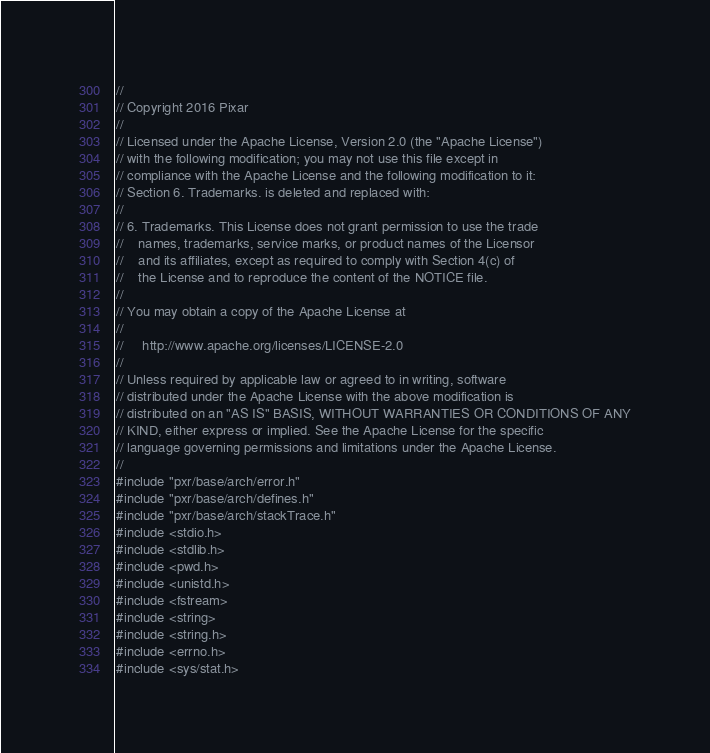Convert code to text. <code><loc_0><loc_0><loc_500><loc_500><_C++_>//
// Copyright 2016 Pixar
//
// Licensed under the Apache License, Version 2.0 (the "Apache License")
// with the following modification; you may not use this file except in
// compliance with the Apache License and the following modification to it:
// Section 6. Trademarks. is deleted and replaced with:
//
// 6. Trademarks. This License does not grant permission to use the trade
//    names, trademarks, service marks, or product names of the Licensor
//    and its affiliates, except as required to comply with Section 4(c) of
//    the License and to reproduce the content of the NOTICE file.
//
// You may obtain a copy of the Apache License at
//
//     http://www.apache.org/licenses/LICENSE-2.0
//
// Unless required by applicable law or agreed to in writing, software
// distributed under the Apache License with the above modification is
// distributed on an "AS IS" BASIS, WITHOUT WARRANTIES OR CONDITIONS OF ANY
// KIND, either express or implied. See the Apache License for the specific
// language governing permissions and limitations under the Apache License.
//
#include "pxr/base/arch/error.h"
#include "pxr/base/arch/defines.h"
#include "pxr/base/arch/stackTrace.h"
#include <stdio.h>
#include <stdlib.h>
#include <pwd.h>
#include <unistd.h>
#include <fstream>
#include <string>
#include <string.h>
#include <errno.h>
#include <sys/stat.h>
</code> 